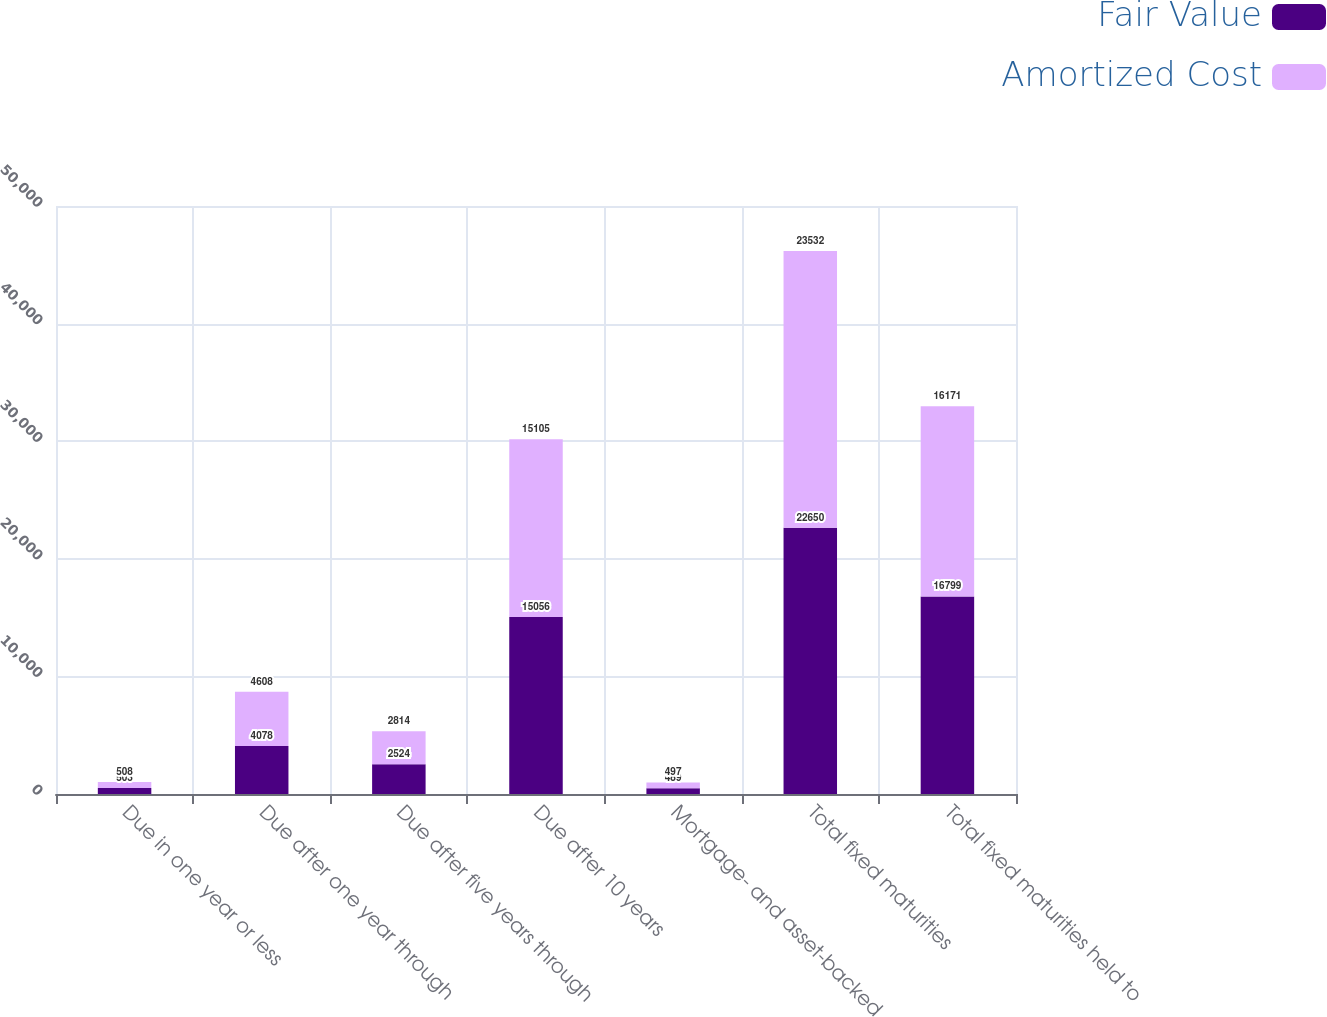Convert chart. <chart><loc_0><loc_0><loc_500><loc_500><stacked_bar_chart><ecel><fcel>Due in one year or less<fcel>Due after one year through<fcel>Due after five years through<fcel>Due after 10 years<fcel>Mortgage- and asset-backed<fcel>Total fixed maturities<fcel>Total fixed maturities held to<nl><fcel>Fair Value<fcel>503<fcel>4078<fcel>2524<fcel>15056<fcel>489<fcel>22650<fcel>16799<nl><fcel>Amortized Cost<fcel>508<fcel>4608<fcel>2814<fcel>15105<fcel>497<fcel>23532<fcel>16171<nl></chart> 